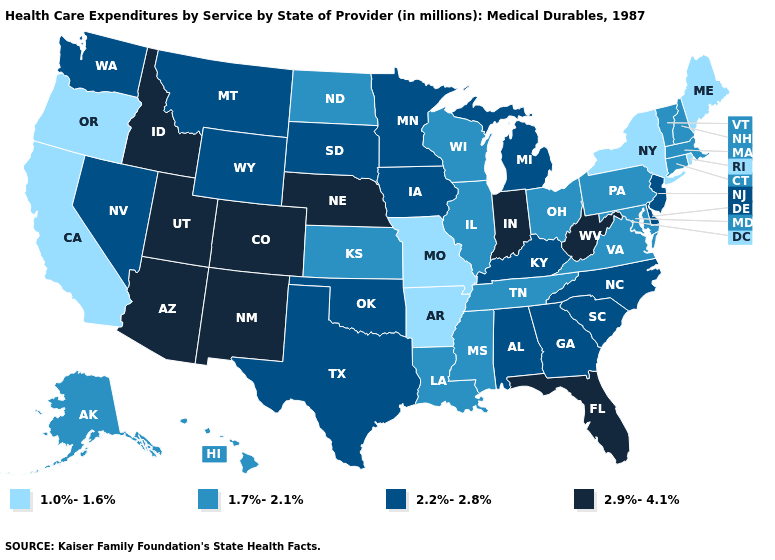What is the highest value in the West ?
Short answer required. 2.9%-4.1%. Name the states that have a value in the range 1.7%-2.1%?
Give a very brief answer. Alaska, Connecticut, Hawaii, Illinois, Kansas, Louisiana, Maryland, Massachusetts, Mississippi, New Hampshire, North Dakota, Ohio, Pennsylvania, Tennessee, Vermont, Virginia, Wisconsin. Does New Mexico have a lower value than Texas?
Write a very short answer. No. Which states have the lowest value in the South?
Keep it brief. Arkansas. Does Alabama have a lower value than West Virginia?
Concise answer only. Yes. What is the value of Connecticut?
Give a very brief answer. 1.7%-2.1%. Name the states that have a value in the range 2.9%-4.1%?
Concise answer only. Arizona, Colorado, Florida, Idaho, Indiana, Nebraska, New Mexico, Utah, West Virginia. Does North Dakota have the highest value in the MidWest?
Concise answer only. No. Among the states that border Georgia , does Florida have the highest value?
Concise answer only. Yes. Does Virginia have the same value as Ohio?
Short answer required. Yes. What is the value of Georgia?
Keep it brief. 2.2%-2.8%. What is the highest value in the West ?
Write a very short answer. 2.9%-4.1%. What is the value of Texas?
Give a very brief answer. 2.2%-2.8%. Does Wyoming have the highest value in the West?
Write a very short answer. No. What is the value of Alabama?
Be succinct. 2.2%-2.8%. 